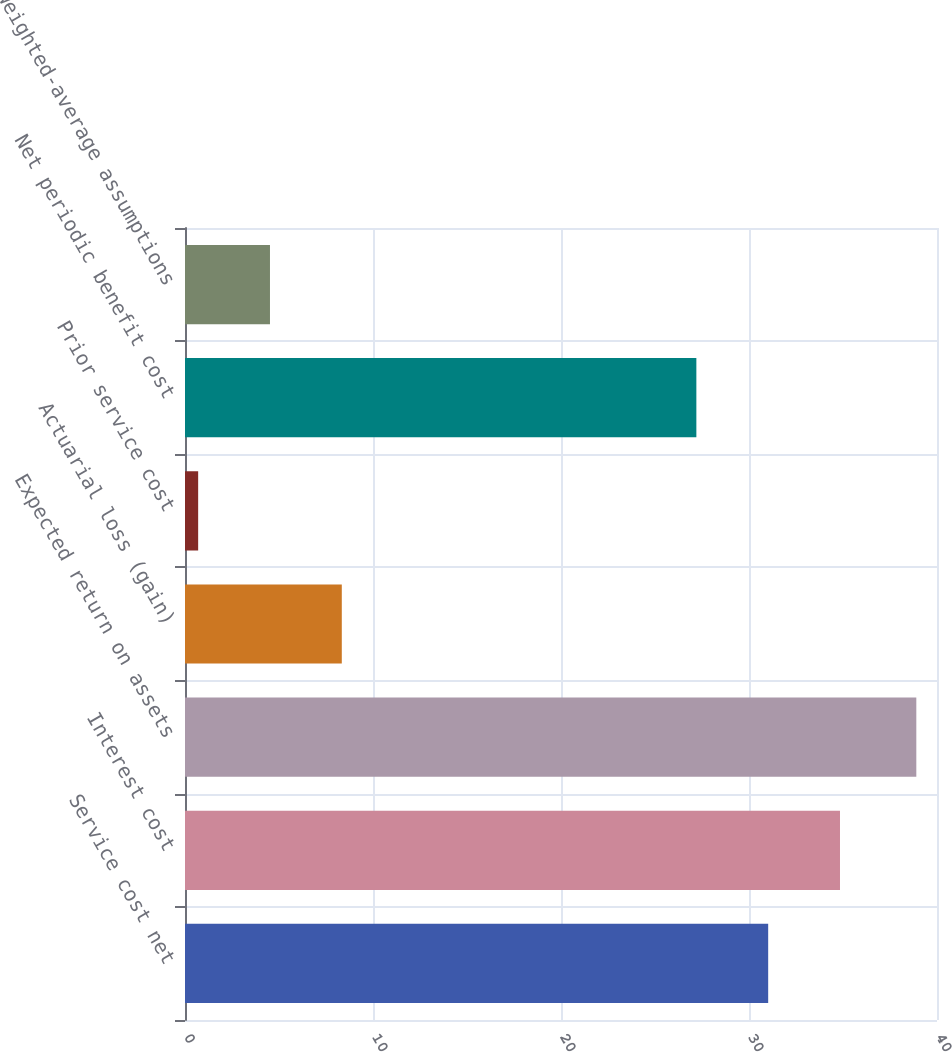<chart> <loc_0><loc_0><loc_500><loc_500><bar_chart><fcel>Service cost net<fcel>Interest cost<fcel>Expected return on assets<fcel>Actuarial loss (gain)<fcel>Prior service cost<fcel>Net periodic benefit cost<fcel>Weighted-average assumptions<nl><fcel>31.02<fcel>34.84<fcel>38.9<fcel>8.34<fcel>0.7<fcel>27.2<fcel>4.52<nl></chart> 